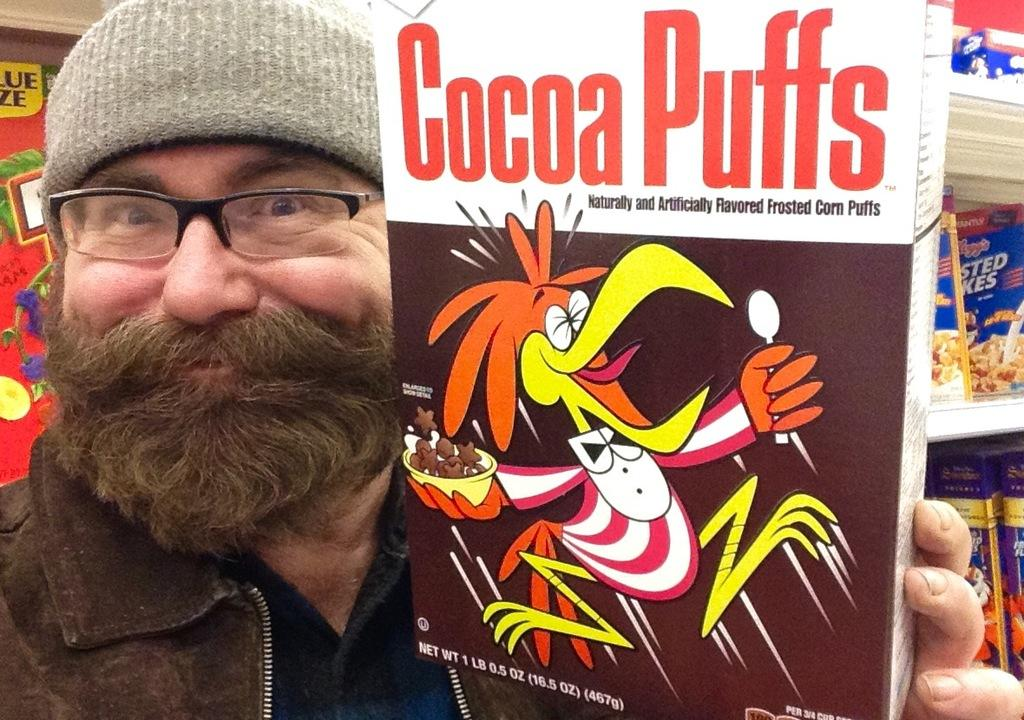What is the man in the image holding? The man is holding a carton in the image. Can you describe the background of the image? There is a shelf in the background of the image. What is placed on the shelves? Goods are placed on the shelves. What type of snake can be seen slithering through the fog in the image? There is no snake or fog present in the image; it features a man holding a carton and a shelf with goods in the background. 